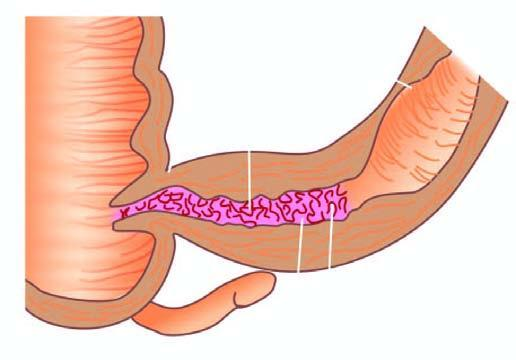does the corresponding area show segment of thickened wall with narrow lumen which is better appreciated in cross section while intervening areas of the bowel are uninvolved or skipped?
Answer the question using a single word or phrase. No 